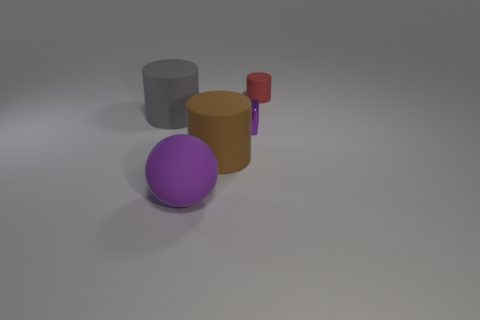What is the shape of the other object that is the same size as the purple shiny object?
Give a very brief answer. Cylinder. Are there any tiny blue rubber objects of the same shape as the purple shiny thing?
Make the answer very short. No. There is a big thing that is in front of the large matte cylinder that is to the right of the gray cylinder; what shape is it?
Make the answer very short. Sphere. There is a tiny purple object; what shape is it?
Keep it short and to the point. Cube. What is the large cylinder on the right side of the big object behind the small thing on the left side of the small matte object made of?
Your answer should be compact. Rubber. What number of other things are there of the same material as the gray cylinder
Keep it short and to the point. 3. What number of big brown rubber things are in front of the small thing that is to the left of the tiny red object?
Your answer should be very brief. 1. How many blocks are big objects or small red things?
Provide a short and direct response. 0. What color is the big object that is to the left of the big brown object and in front of the purple block?
Keep it short and to the point. Purple. Is there any other thing of the same color as the metallic object?
Provide a succinct answer. Yes. 